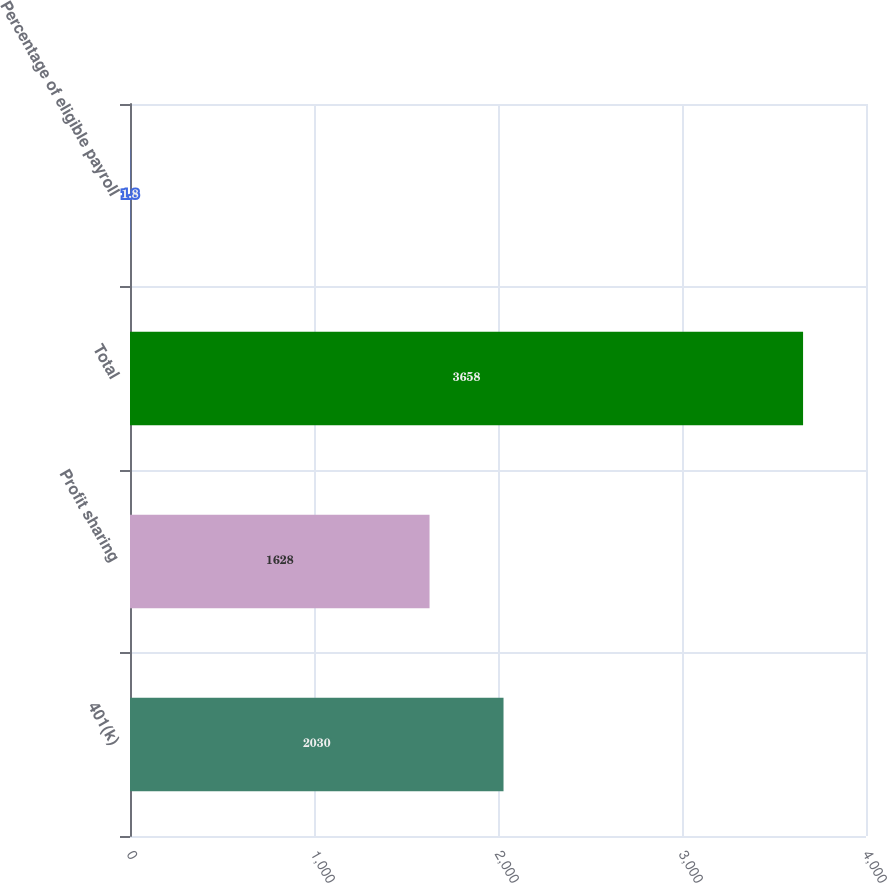Convert chart to OTSL. <chart><loc_0><loc_0><loc_500><loc_500><bar_chart><fcel>401(k)<fcel>Profit sharing<fcel>Total<fcel>Percentage of eligible payroll<nl><fcel>2030<fcel>1628<fcel>3658<fcel>1.8<nl></chart> 